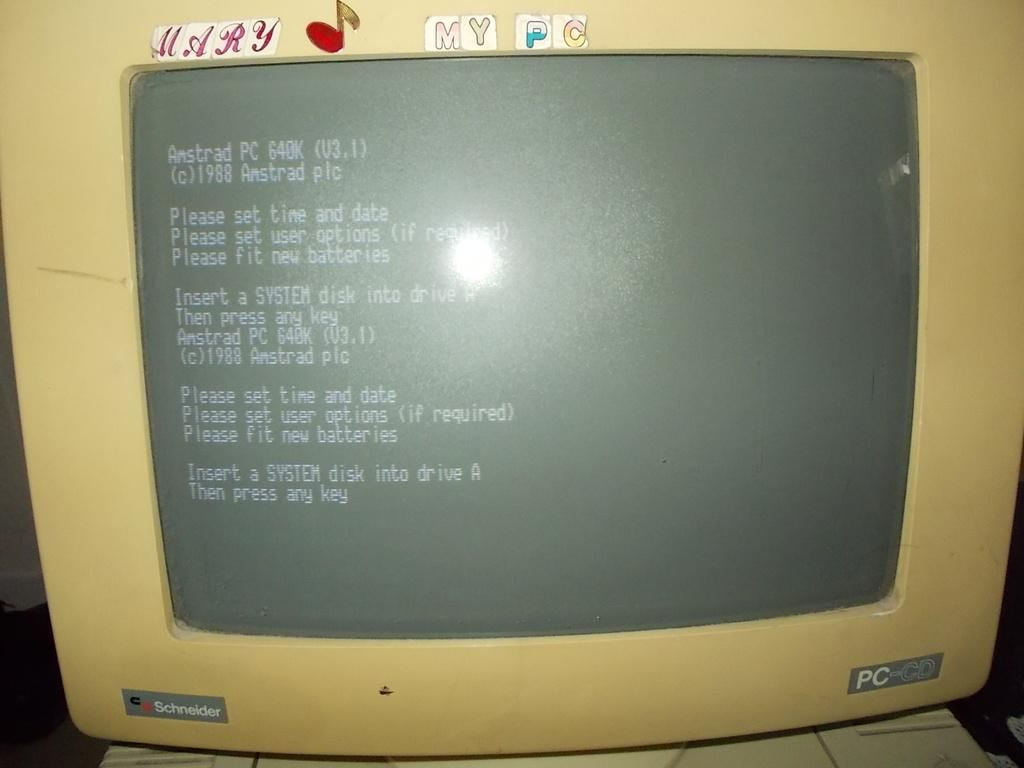<image>
Share a concise interpretation of the image provided. a computer screen that says 'amstrad pc 640k' at the top 